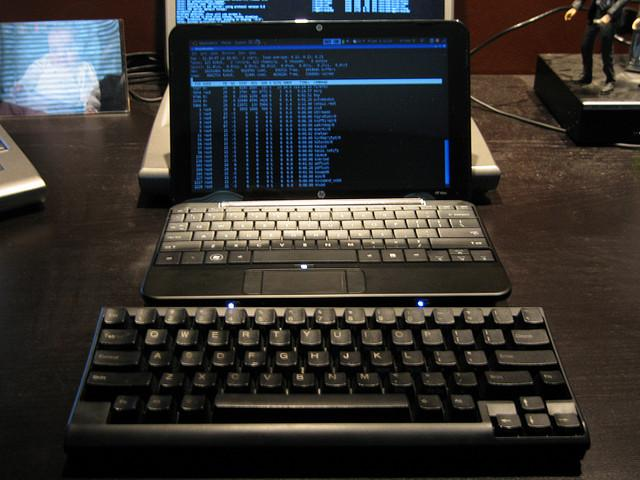Based on what's shown on the computer screen what is this person doing? programming 